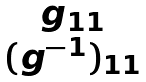<formula> <loc_0><loc_0><loc_500><loc_500>\begin{matrix} g _ { 1 1 } \\ ( g ^ { - 1 } ) _ { 1 1 } \end{matrix}</formula> 